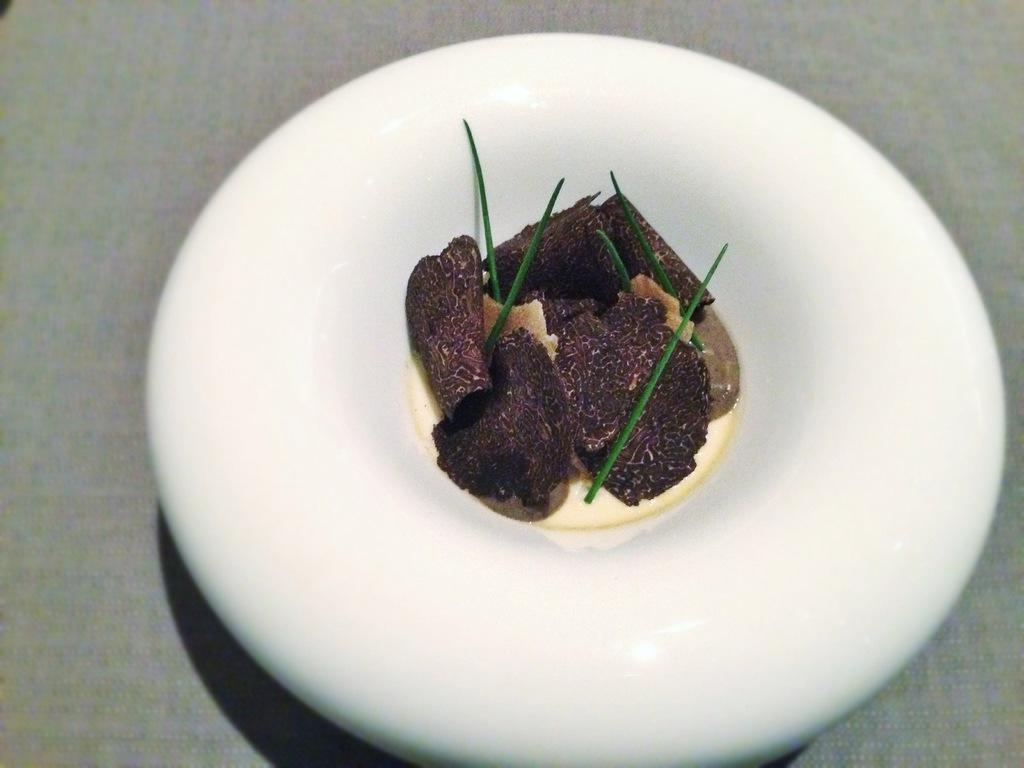What is on the plate that is visible in the image? There is food on a plate in the image. Where is the plate located in the image? The plate is in the center of the image. What type of disgust can be seen on the plate in the image? There is no disgust present on the plate in the image; it contains food. Can you tell me how many pieces of popcorn are on the plate in the image? There is no popcorn present on the plate in the image; it contains food. 